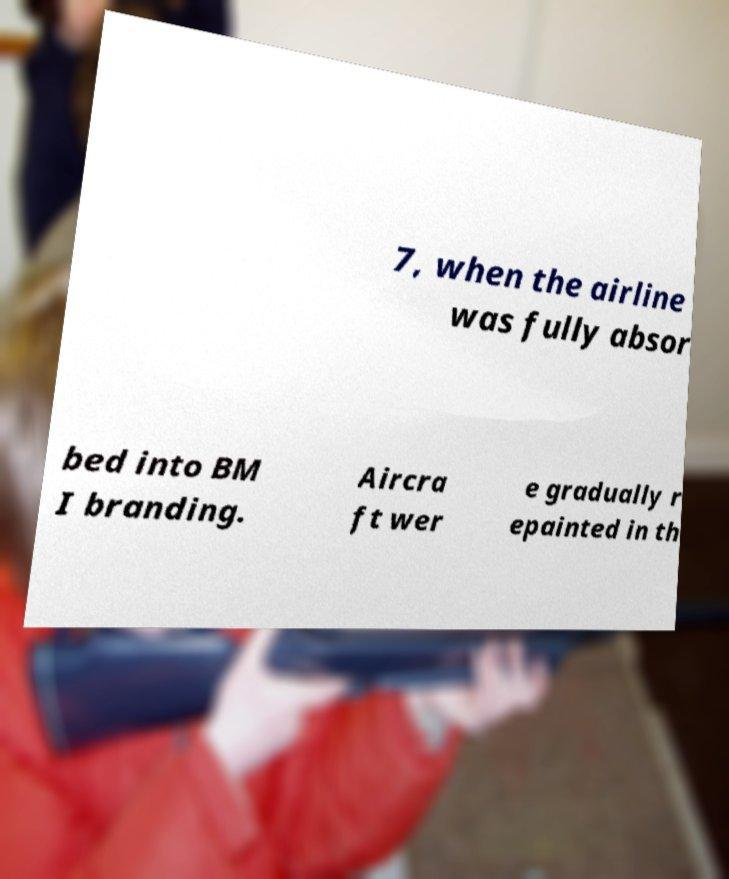Can you accurately transcribe the text from the provided image for me? 7, when the airline was fully absor bed into BM I branding. Aircra ft wer e gradually r epainted in th 